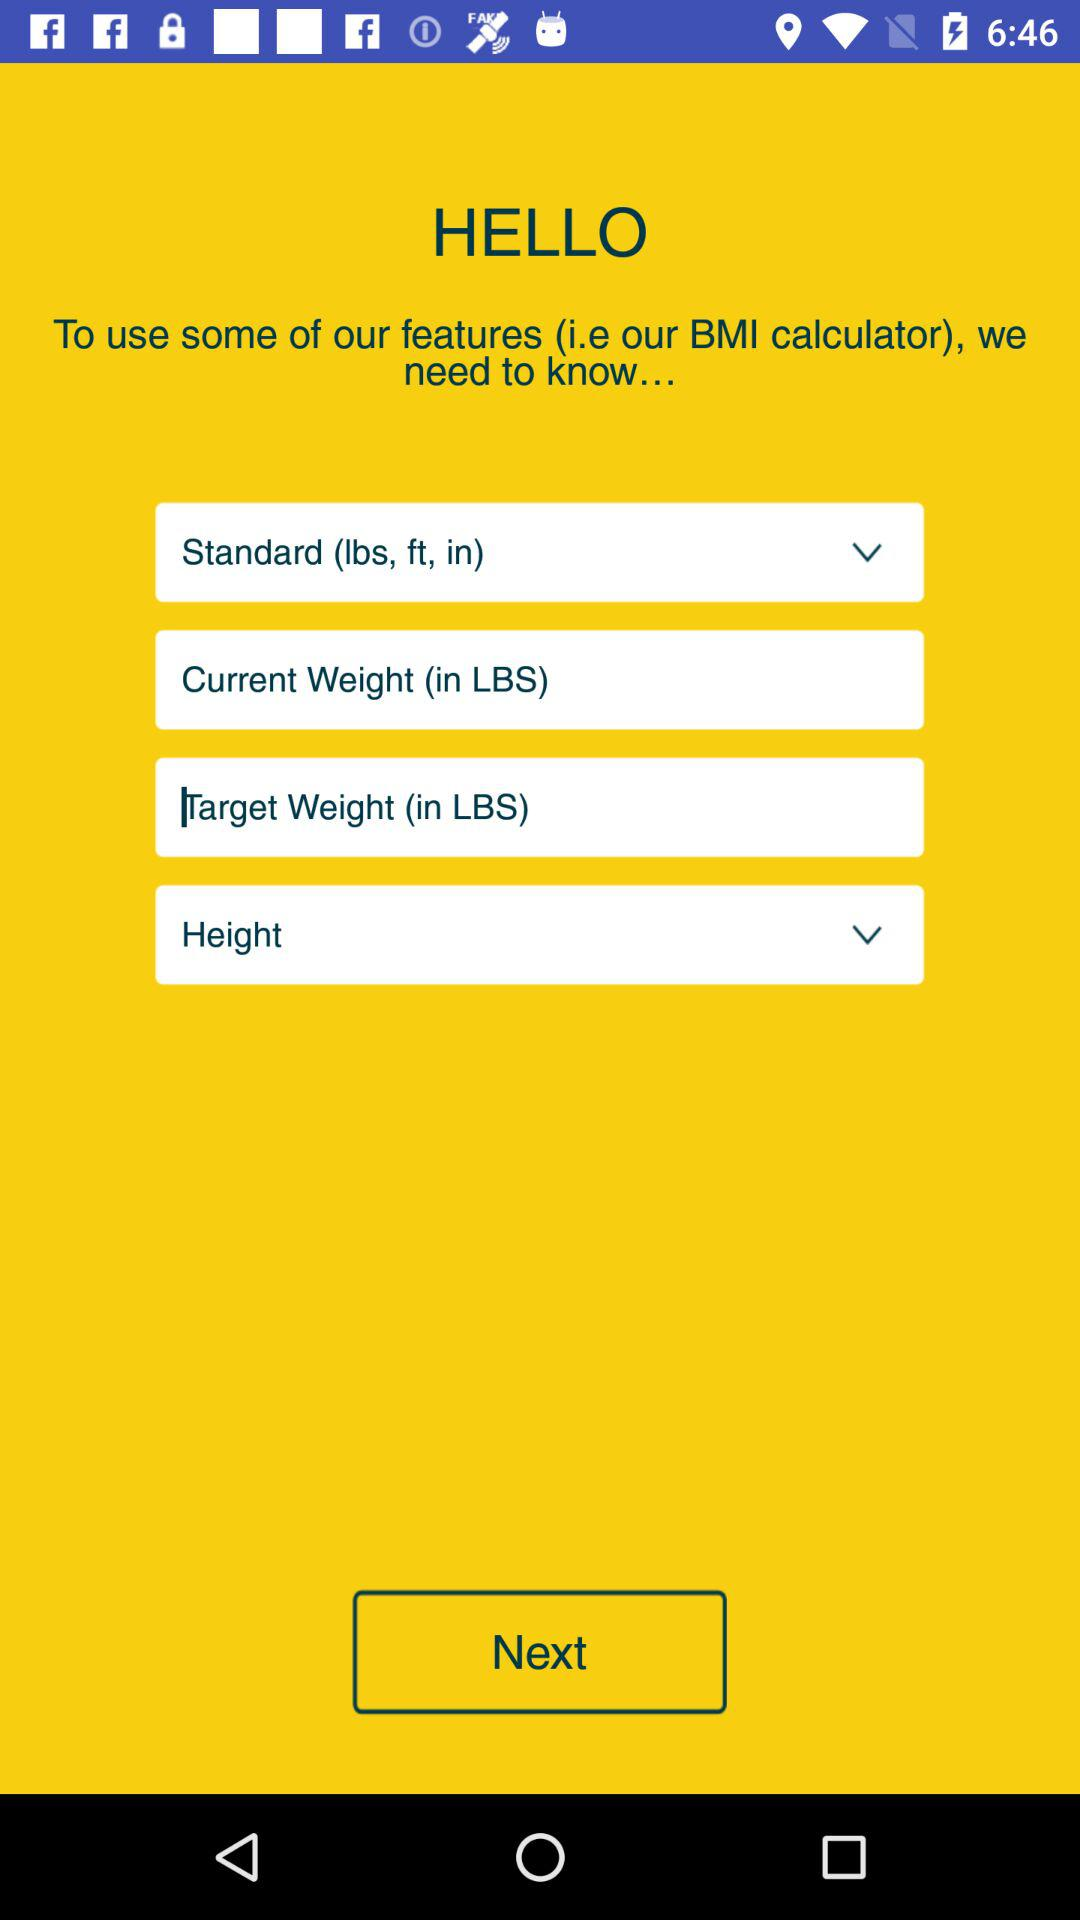What is the application name? The application name is "BMI calculator". 